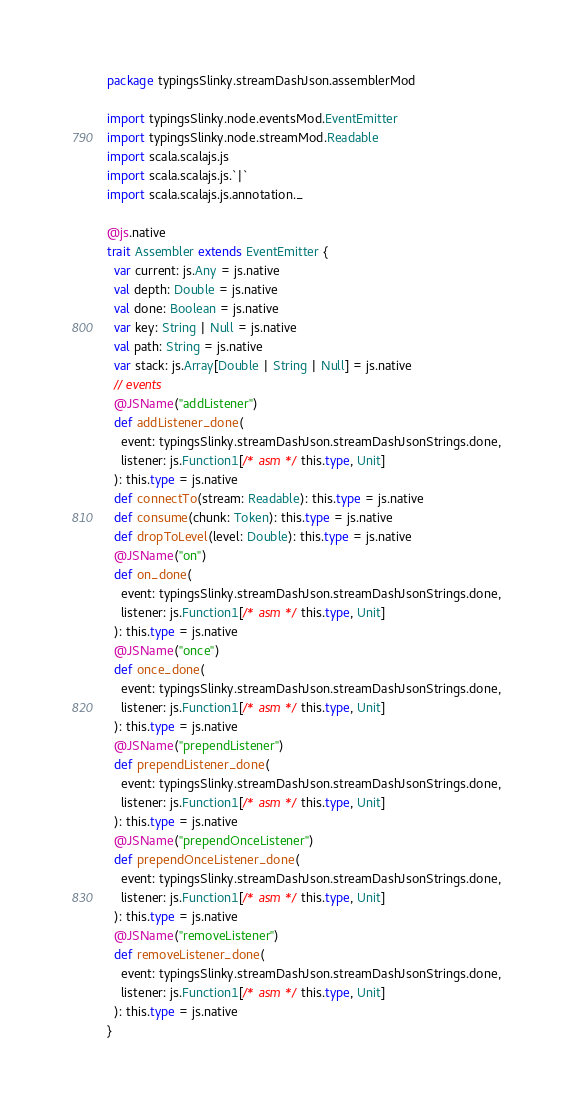<code> <loc_0><loc_0><loc_500><loc_500><_Scala_>package typingsSlinky.streamDashJson.assemblerMod

import typingsSlinky.node.eventsMod.EventEmitter
import typingsSlinky.node.streamMod.Readable
import scala.scalajs.js
import scala.scalajs.js.`|`
import scala.scalajs.js.annotation._

@js.native
trait Assembler extends EventEmitter {
  var current: js.Any = js.native
  val depth: Double = js.native
  val done: Boolean = js.native
  var key: String | Null = js.native
  val path: String = js.native
  var stack: js.Array[Double | String | Null] = js.native
  // events
  @JSName("addListener")
  def addListener_done(
    event: typingsSlinky.streamDashJson.streamDashJsonStrings.done,
    listener: js.Function1[/* asm */ this.type, Unit]
  ): this.type = js.native
  def connectTo(stream: Readable): this.type = js.native
  def consume(chunk: Token): this.type = js.native
  def dropToLevel(level: Double): this.type = js.native
  @JSName("on")
  def on_done(
    event: typingsSlinky.streamDashJson.streamDashJsonStrings.done,
    listener: js.Function1[/* asm */ this.type, Unit]
  ): this.type = js.native
  @JSName("once")
  def once_done(
    event: typingsSlinky.streamDashJson.streamDashJsonStrings.done,
    listener: js.Function1[/* asm */ this.type, Unit]
  ): this.type = js.native
  @JSName("prependListener")
  def prependListener_done(
    event: typingsSlinky.streamDashJson.streamDashJsonStrings.done,
    listener: js.Function1[/* asm */ this.type, Unit]
  ): this.type = js.native
  @JSName("prependOnceListener")
  def prependOnceListener_done(
    event: typingsSlinky.streamDashJson.streamDashJsonStrings.done,
    listener: js.Function1[/* asm */ this.type, Unit]
  ): this.type = js.native
  @JSName("removeListener")
  def removeListener_done(
    event: typingsSlinky.streamDashJson.streamDashJsonStrings.done,
    listener: js.Function1[/* asm */ this.type, Unit]
  ): this.type = js.native
}

</code> 